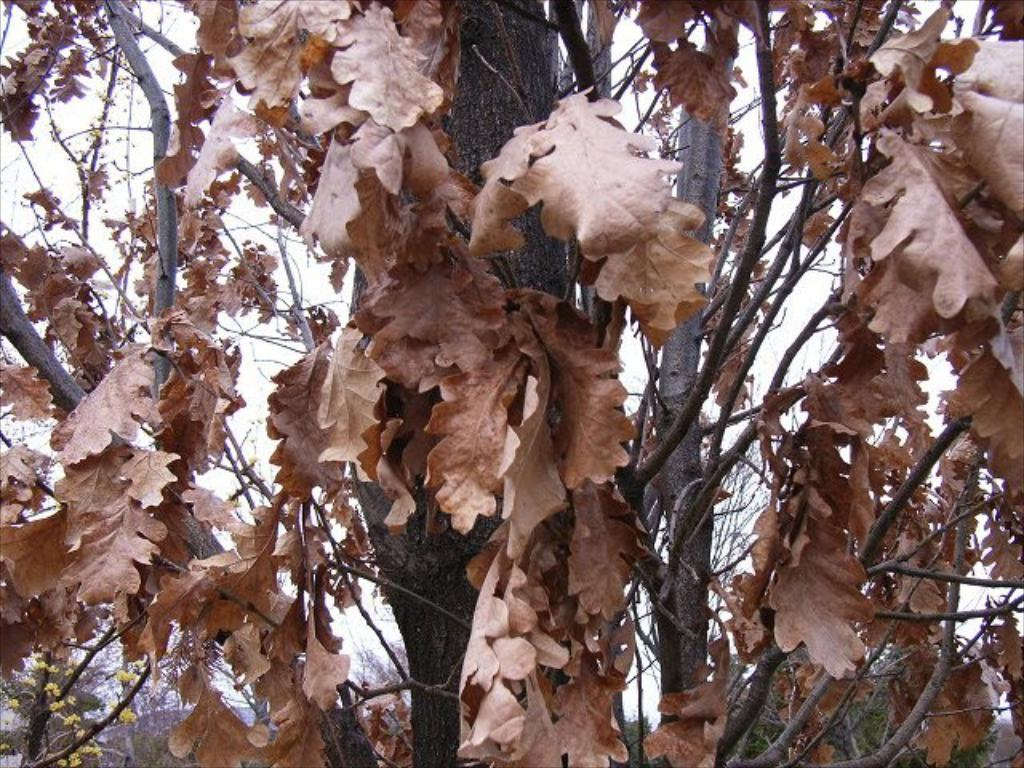What type of plant can be seen in the image? There is a tree in the image. What is present on the ground around the tree? Dry leaves are present in the image. What can be seen above the tree in the image? The sky is visible in the image. What type of flowers are present on the tree? There are tiny yellow flowers in the image. How much money is hanging from the tree in the image? There is no money hanging from the tree in the image. Is there an umbrella visible in the image? No, there is no umbrella present in the image. 